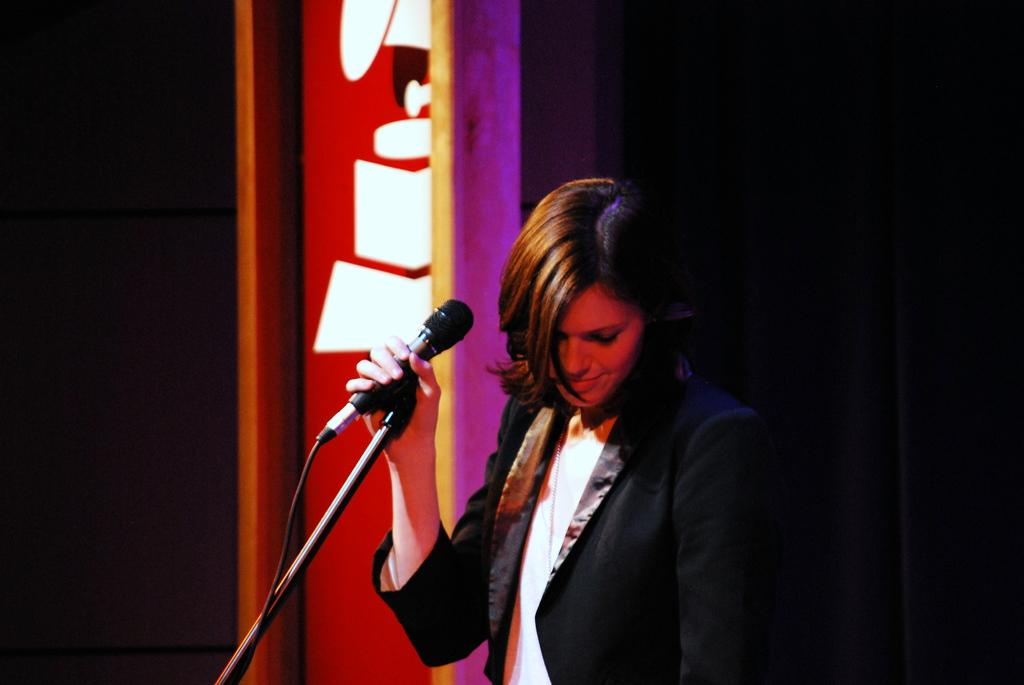Who is the main subject in the image? There is a woman in the image. What is the woman doing in the image? The woman is catching a microphone. What type of sidewalk can be seen in the image? There is no sidewalk present in the image. 